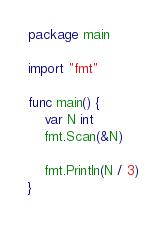<code> <loc_0><loc_0><loc_500><loc_500><_Go_>package main

import "fmt"

func main() {
	var N int
	fmt.Scan(&N)

	fmt.Println(N / 3)
}
</code> 